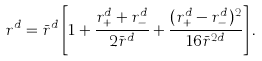Convert formula to latex. <formula><loc_0><loc_0><loc_500><loc_500>r ^ { d } = \bar { r } ^ { d } \left [ 1 + \frac { r _ { + } ^ { d } + r _ { - } ^ { d } } { 2 \bar { r } ^ { d } } + \frac { ( r _ { + } ^ { d } - r _ { - } ^ { d } ) ^ { 2 } } { 1 6 \bar { r } ^ { 2 d } } \right ] .</formula> 